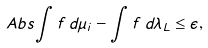<formula> <loc_0><loc_0><loc_500><loc_500>\ A b s { \int f \, d \mu _ { i } - \int f \, d \lambda _ { L } } \leq \epsilon ,</formula> 